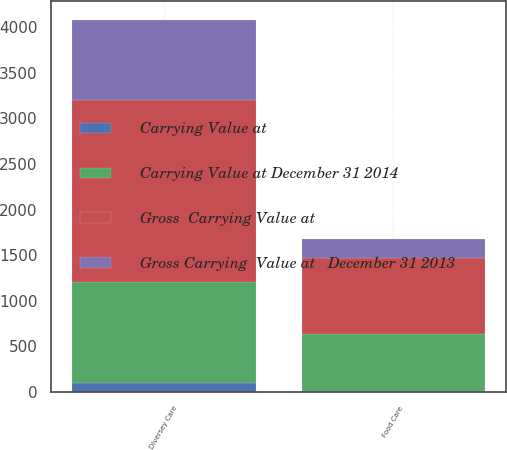Convert chart to OTSL. <chart><loc_0><loc_0><loc_500><loc_500><stacked_bar_chart><ecel><fcel>Food Care<fcel>Diversey Care<nl><fcel>Gross  Carrying Value at<fcel>833.7<fcel>1994.1<nl><fcel>Gross Carrying  Value at   December 31 2013<fcel>208<fcel>883<nl><fcel>Carrying Value at December 31 2014<fcel>625.7<fcel>1111.1<nl><fcel>Carrying Value at<fcel>14<fcel>93.3<nl></chart> 